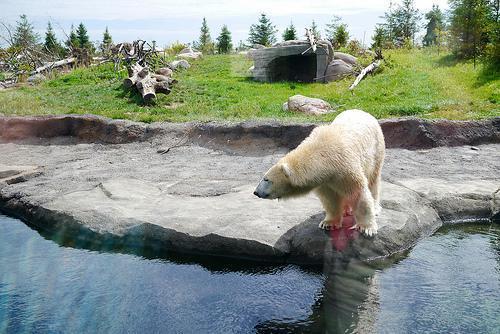How many bears are in the photo?
Give a very brief answer. 1. 